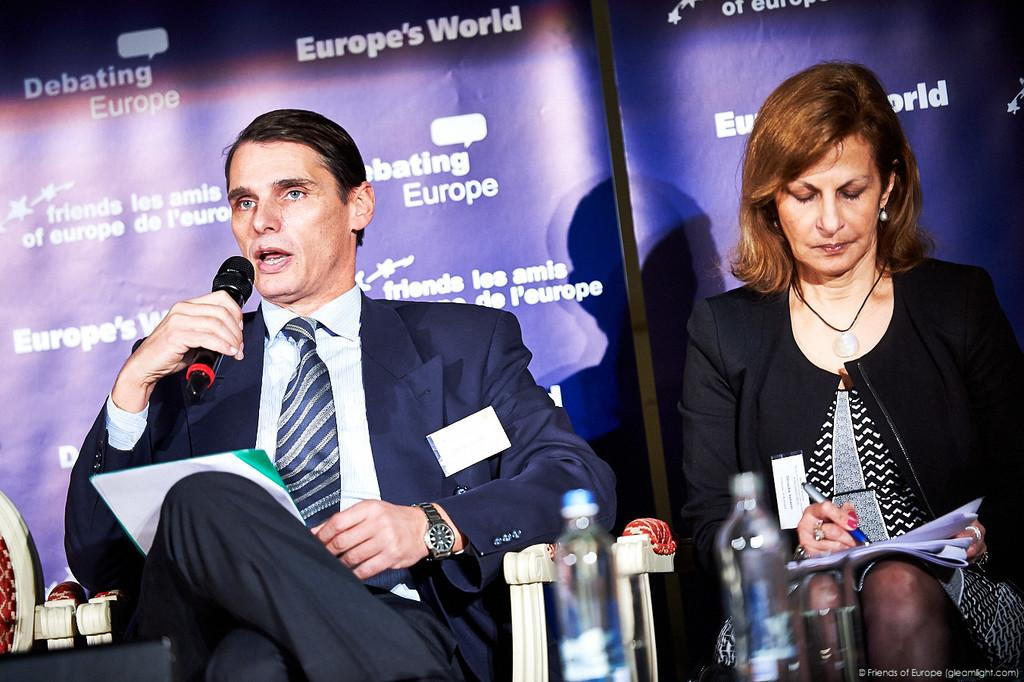How many people are in the image? There are two people in the image, a man and a woman. What are the man and woman doing in the image? The man is talking on a microphone, and the woman is writing on a paper. What objects can be seen in the image besides the people? There are bottles in the image. What is visible in the background of the image? There are banners in the background of the image. What type of floor can be seen in the image? There is no information about the floor in the image. 